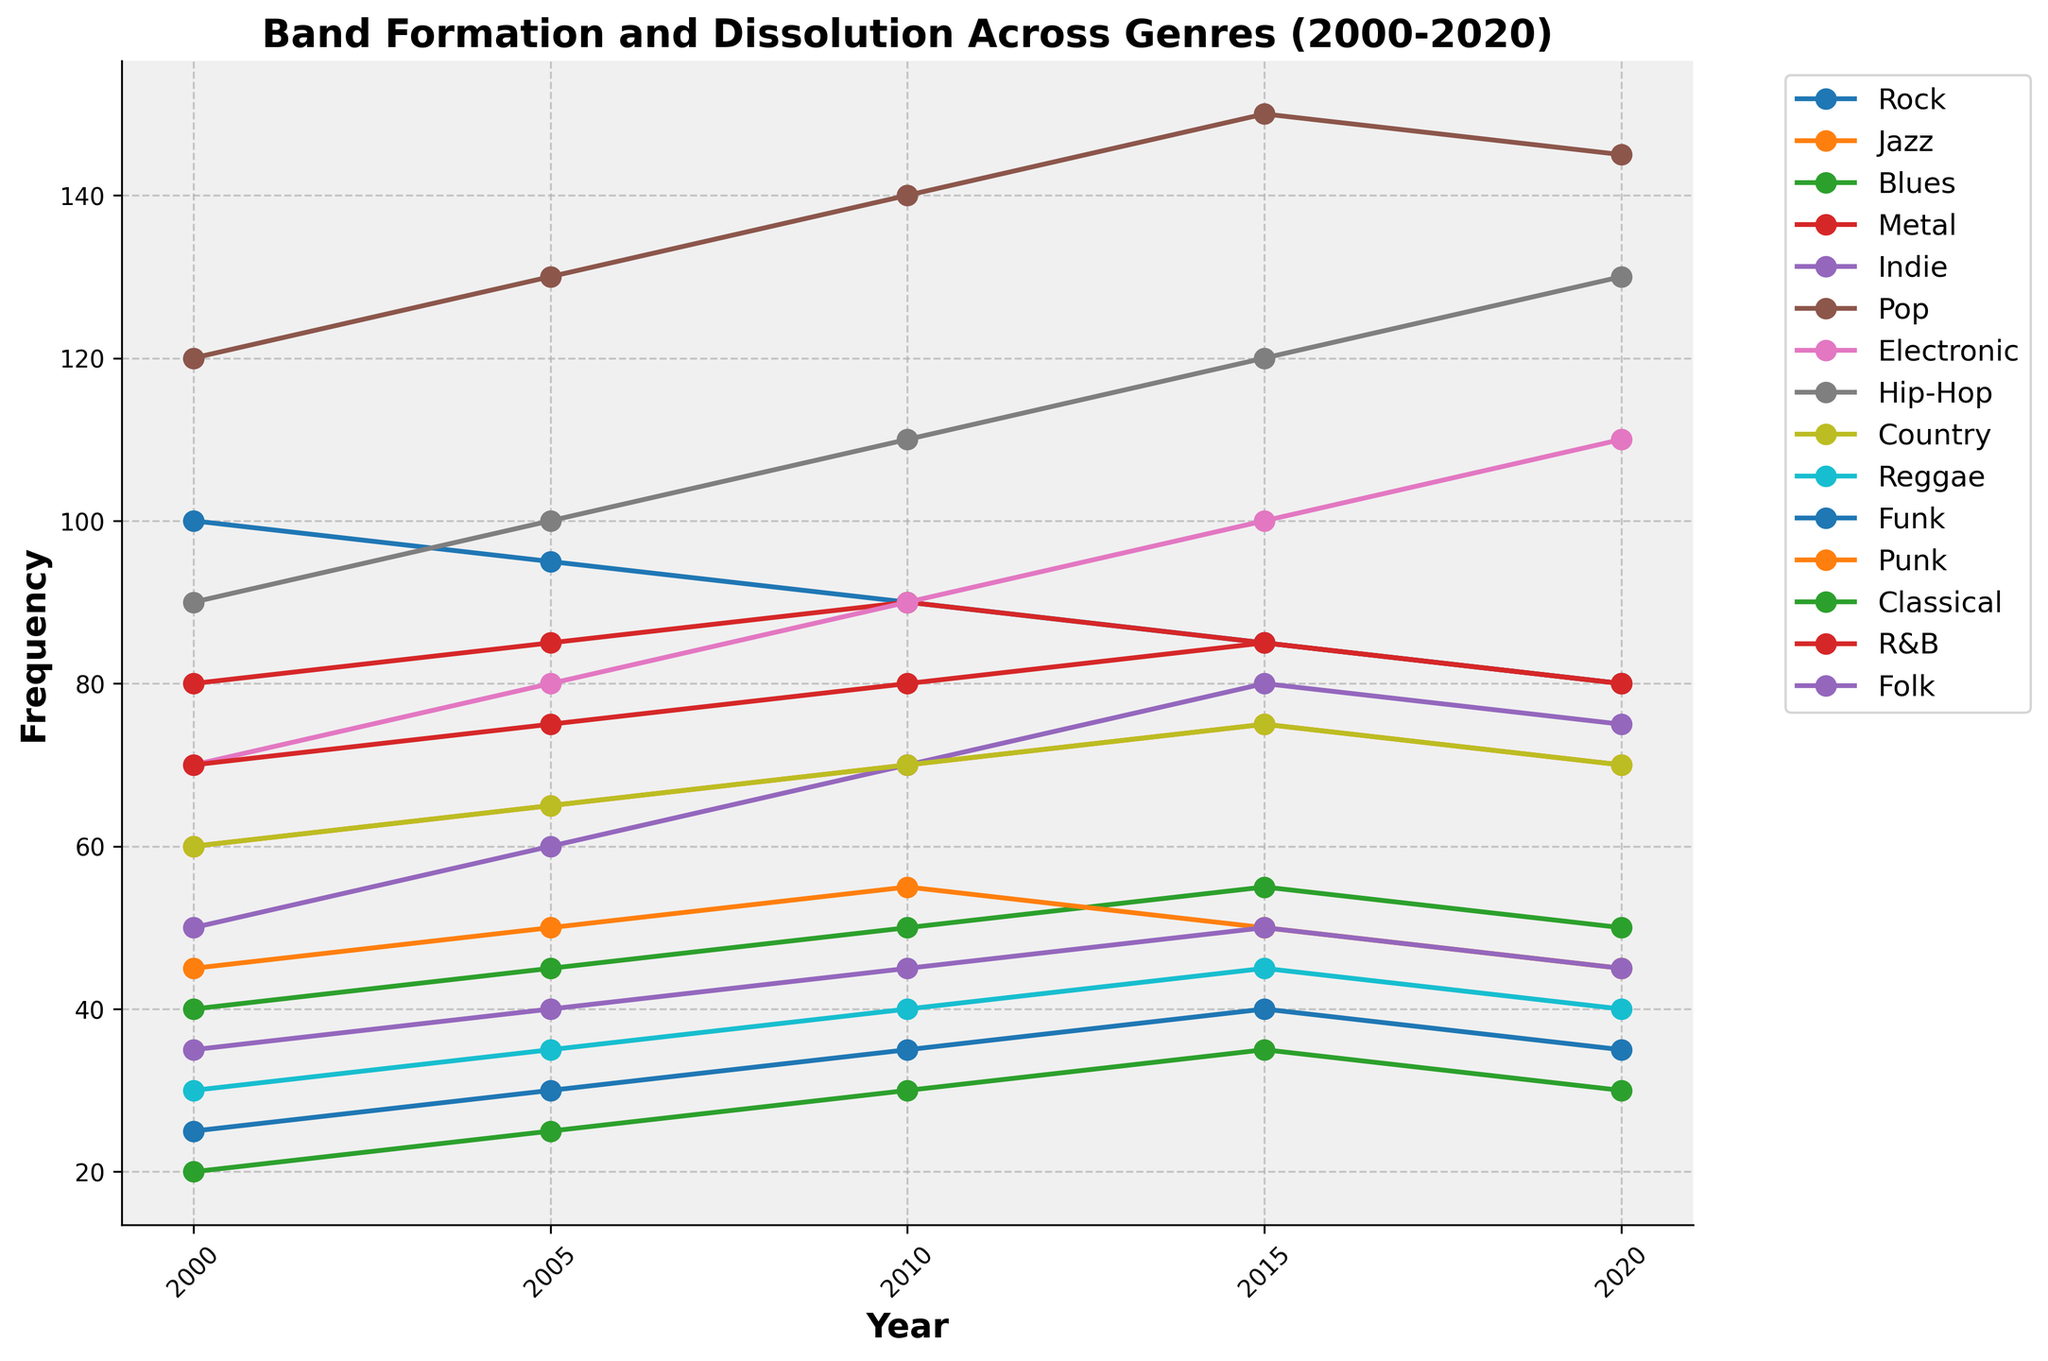What's the overall trend in the frequency of Rock bands from 2000 to 2020? The frequency of Rock bands decreases over the years. Start at 100 in 2000, then progressively drop to 80 by 2020. Observing the trend, it consistently goes down.
Answer: Decreasing Which genre had the highest frequency in 2020? To find the highest frequency in 2020, look at the end point of each line in the plot and detect the highest value. Pop has the highest frequency in 2020 with a value of 145.
Answer: Pop Which two genres had the same frequency in both 2000 and 2020? Look at the beginning and end points of each line. Rock and Metal both start at 100 and end at 80, making them the pairs with identical frequencies for both years.
Answer: Rock and Metal What is the average frequency of Electronic bands from 2000 to 2020? Calculate the average by summing the values (70 + 80 + 90 + 100 + 110 = 450), then divide by 5 (450/5).
Answer: 90 Which genre showed the most significant increase in frequency from 2000 to 2020? Compare the beginning and end points for each genre. Hip-Hop and Electronic both show strong increases, but Hip-Hop rises from 90 to 130, which is the largest gain (40).
Answer: Hip-Hop In which year did Jazz and Country bands share the same frequency? Look for the intersection of Jazz and Country lines. Both have the same frequency of 70 in both 2010 and 2020.
Answer: 2010 and 2020 What is the total frequency of bands formed across all genres in 2000? Sum the frequencies for all genres in 2000 (100 + 60 + 40 + 80 + 50 + 120 + 70 + 90 + 60 + 30 + 25 + 45 + 20 + 70 + 35). Total = 895.
Answer: 895 Which genre has a consistent pattern without fluctuations between 2000 to 2020? Examine the plot for lines that only go up or down or remain steady without any short-term up-down variations. The Rock genre line consistently decreases without fluctuation.
Answer: Rock How did the frequency of Punk bands change from 2010 to 2020? Observe the Punk band's values from 2010 to 2020. Notice that in 2010 the frequency was 55, decreased to 50 by 2015, and further decreased to 45 by 2020. The overall change is a decline.
Answer: Decrease In which years did Classical and Reggae bands have the exact frequencies? Look for the intersecting points between Classical and Reggae lines. Both lines intersect two times: once in 2010 (both at 30) and in 2020 (both at 40).
Answer: 2010 and 2020 